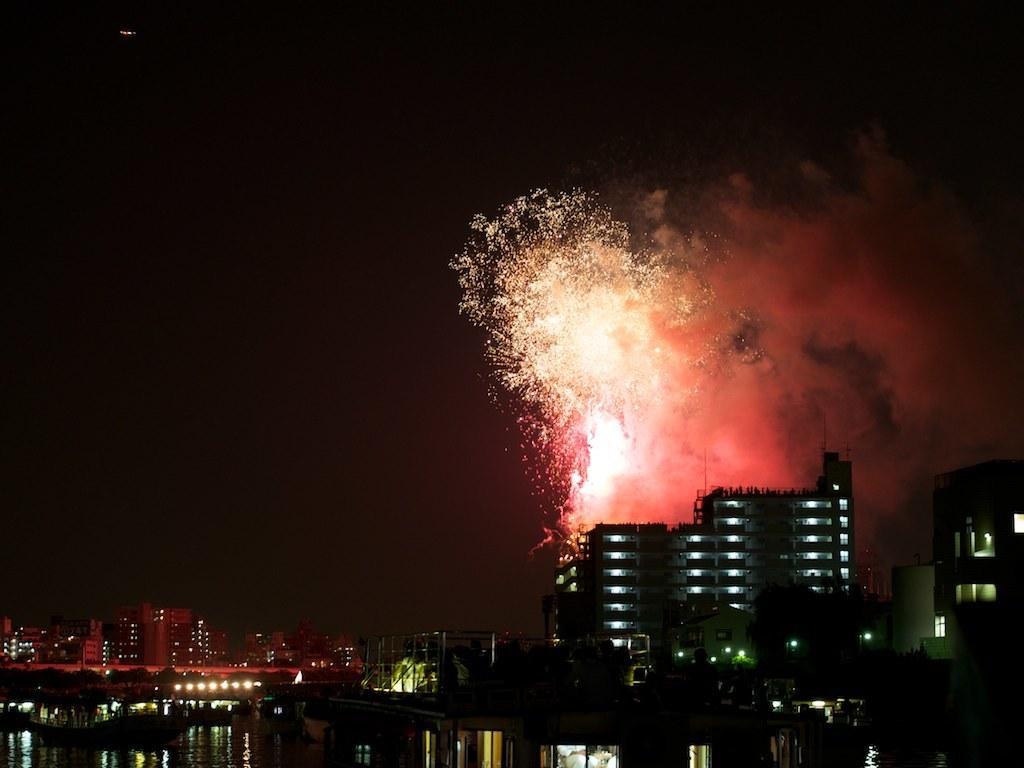Could you give a brief overview of what you see in this image? In this image there is water at the bottom. In the middle there are so many buildings, one beside the other. At the top there are lights of crackers. This image is taken during the night time. 